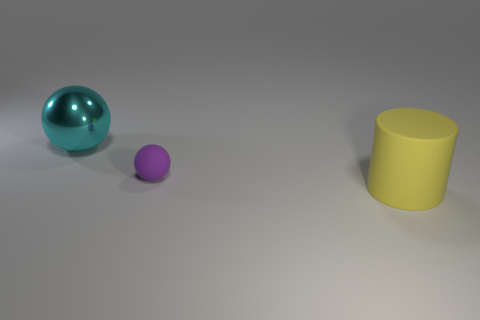Add 2 purple matte balls. How many objects exist? 5 Subtract all cylinders. How many objects are left? 2 Subtract 1 balls. How many balls are left? 1 Subtract all purple spheres. How many spheres are left? 1 Subtract all shiny balls. Subtract all large blue objects. How many objects are left? 2 Add 3 big cyan things. How many big cyan things are left? 4 Add 1 tiny red rubber cylinders. How many tiny red rubber cylinders exist? 1 Subtract 1 purple spheres. How many objects are left? 2 Subtract all green balls. Subtract all brown blocks. How many balls are left? 2 Subtract all yellow cylinders. How many purple balls are left? 1 